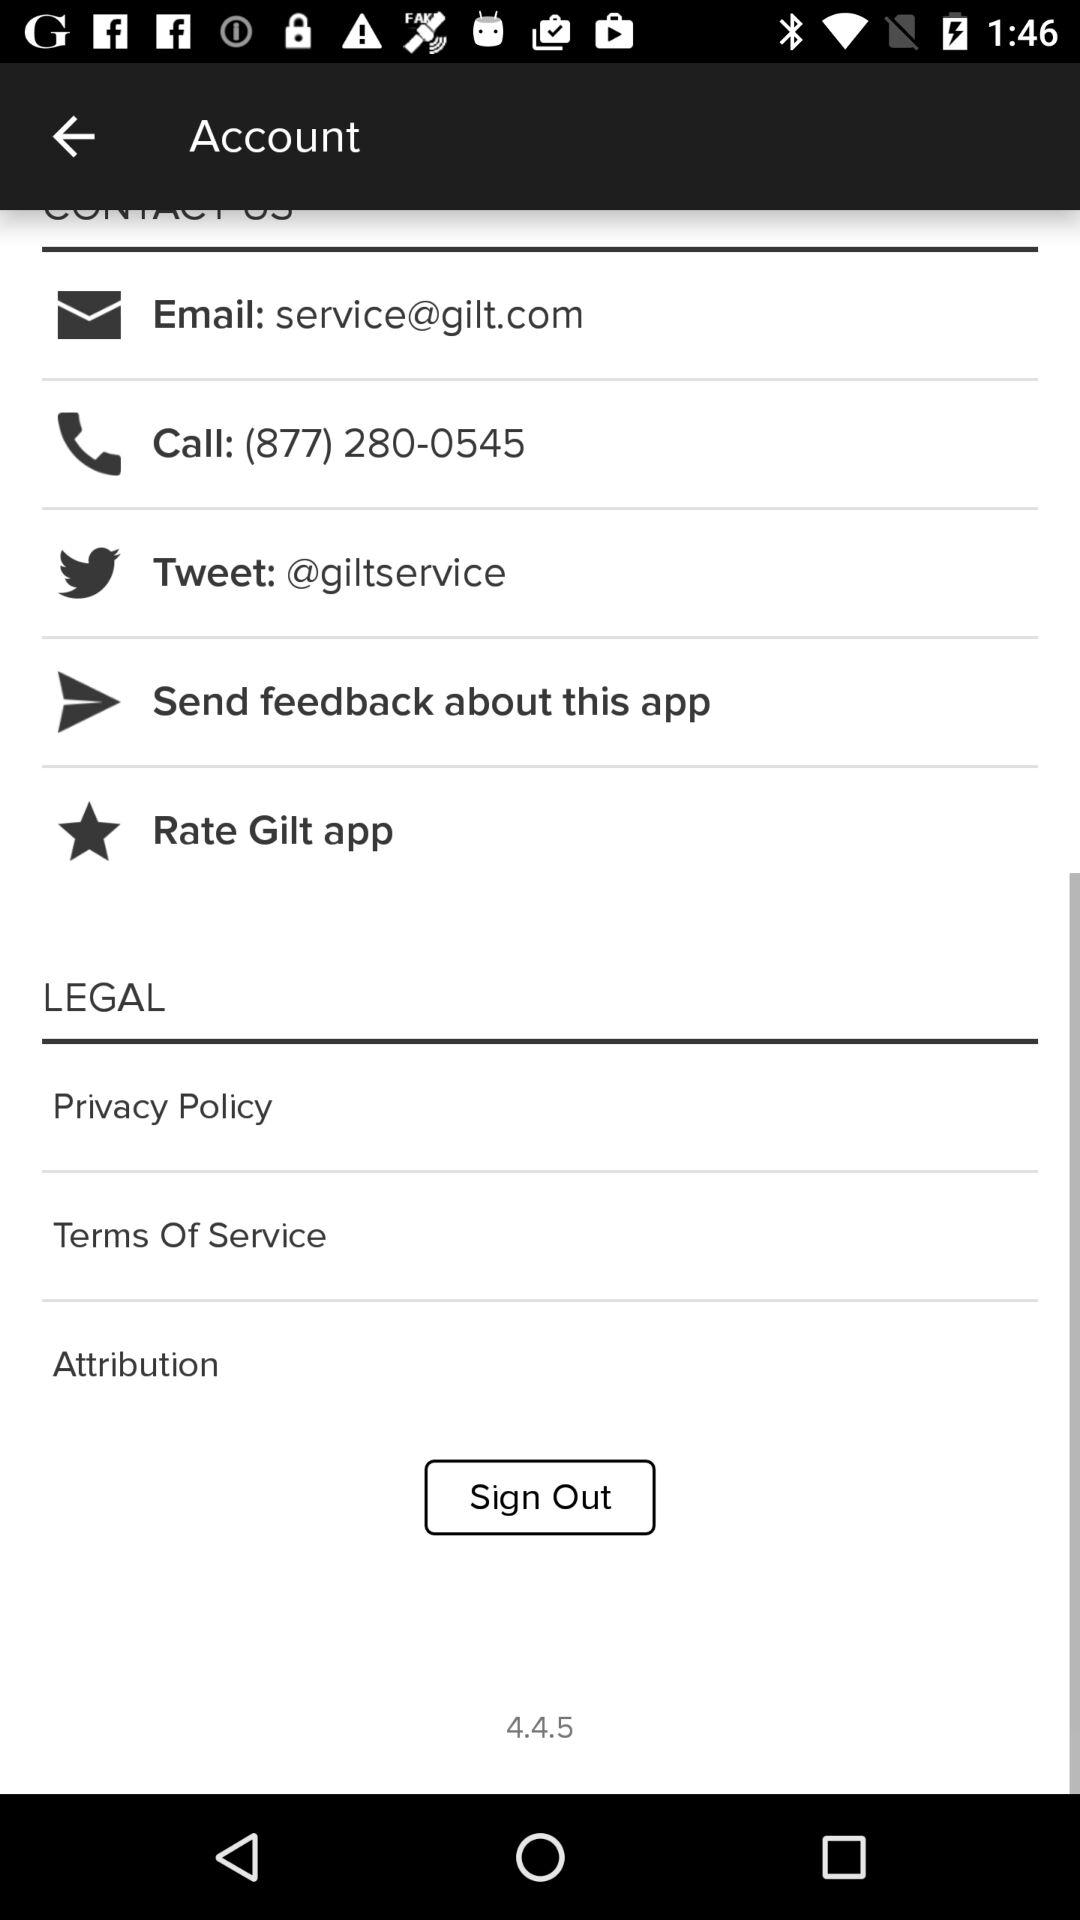What is the "Twitter" ID? The "Twitter" ID is @giltservice. 